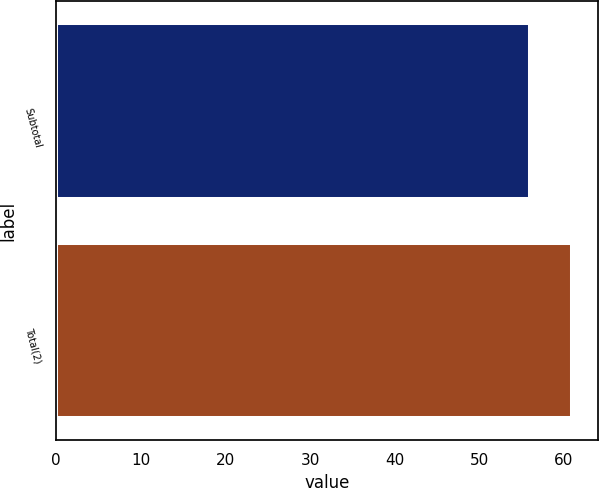<chart> <loc_0><loc_0><loc_500><loc_500><bar_chart><fcel>Subtotal<fcel>Total(2)<nl><fcel>56<fcel>61<nl></chart> 